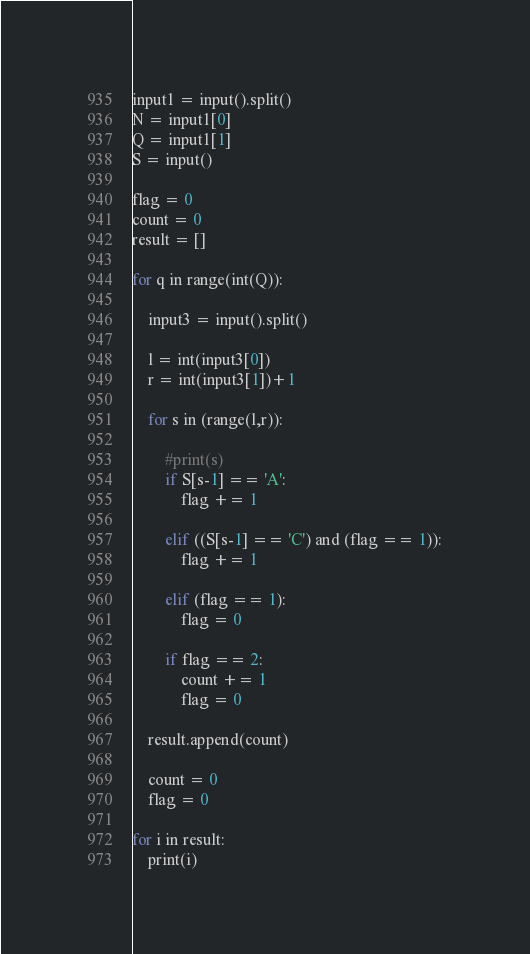Convert code to text. <code><loc_0><loc_0><loc_500><loc_500><_Python_>input1 = input().split()
N = input1[0]
Q = input1[1]
S = input()

flag = 0
count = 0
result = []

for q in range(int(Q)):
	
	input3 = input().split()
	
	l = int(input3[0])
	r = int(input3[1])+1
	
	for s in (range(l,r)):
		
		#print(s)
		if S[s-1] == 'A':
			flag += 1
			
		elif ((S[s-1] == 'C') and (flag == 1)):
			flag += 1
			
		elif (flag == 1):
			flag = 0
		
		if flag == 2:
			count += 1
			flag = 0
			
	result.append(count)
	
	count = 0
	flag = 0
	
for i in result:
	print(i)

</code> 